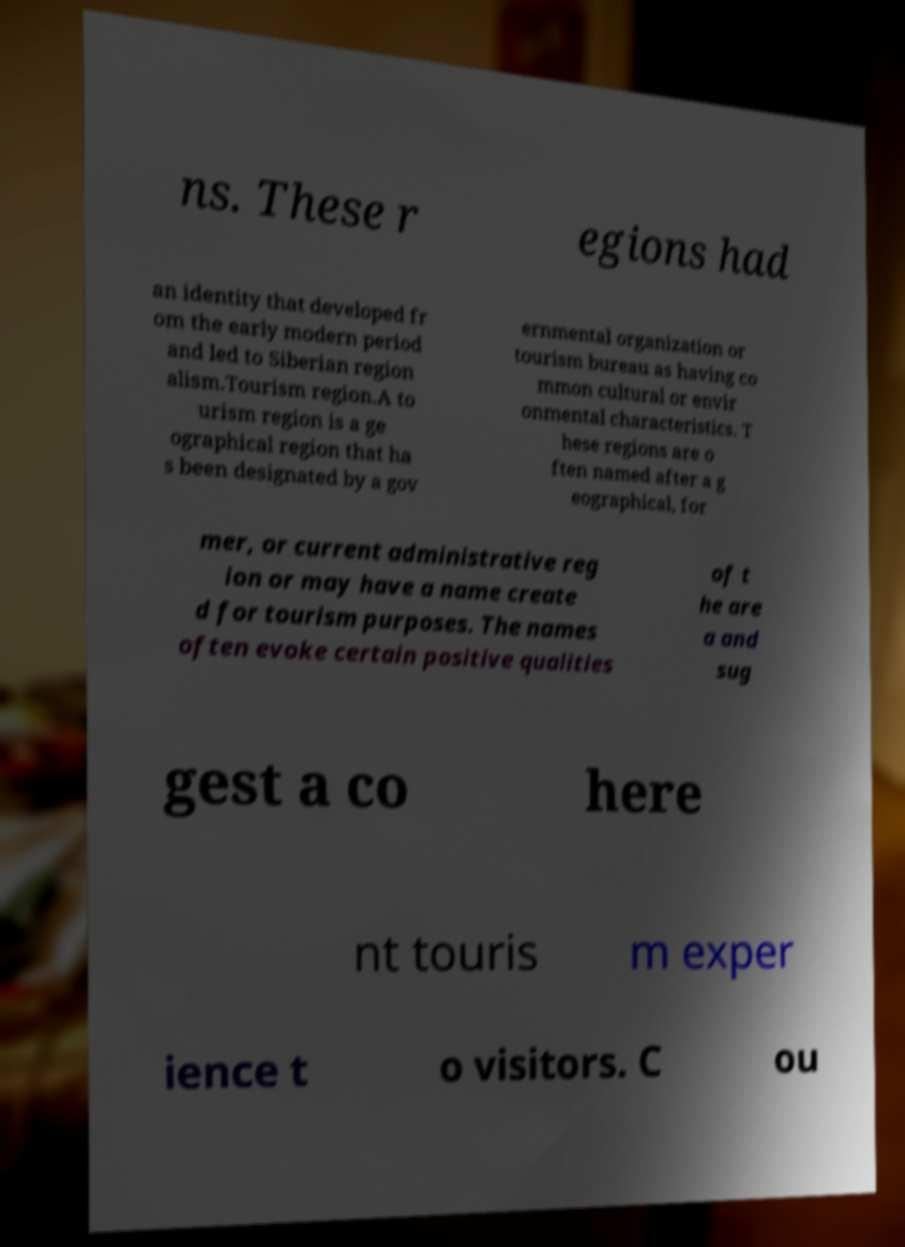Please identify and transcribe the text found in this image. ns. These r egions had an identity that developed fr om the early modern period and led to Siberian region alism.Tourism region.A to urism region is a ge ographical region that ha s been designated by a gov ernmental organization or tourism bureau as having co mmon cultural or envir onmental characteristics. T hese regions are o ften named after a g eographical, for mer, or current administrative reg ion or may have a name create d for tourism purposes. The names often evoke certain positive qualities of t he are a and sug gest a co here nt touris m exper ience t o visitors. C ou 